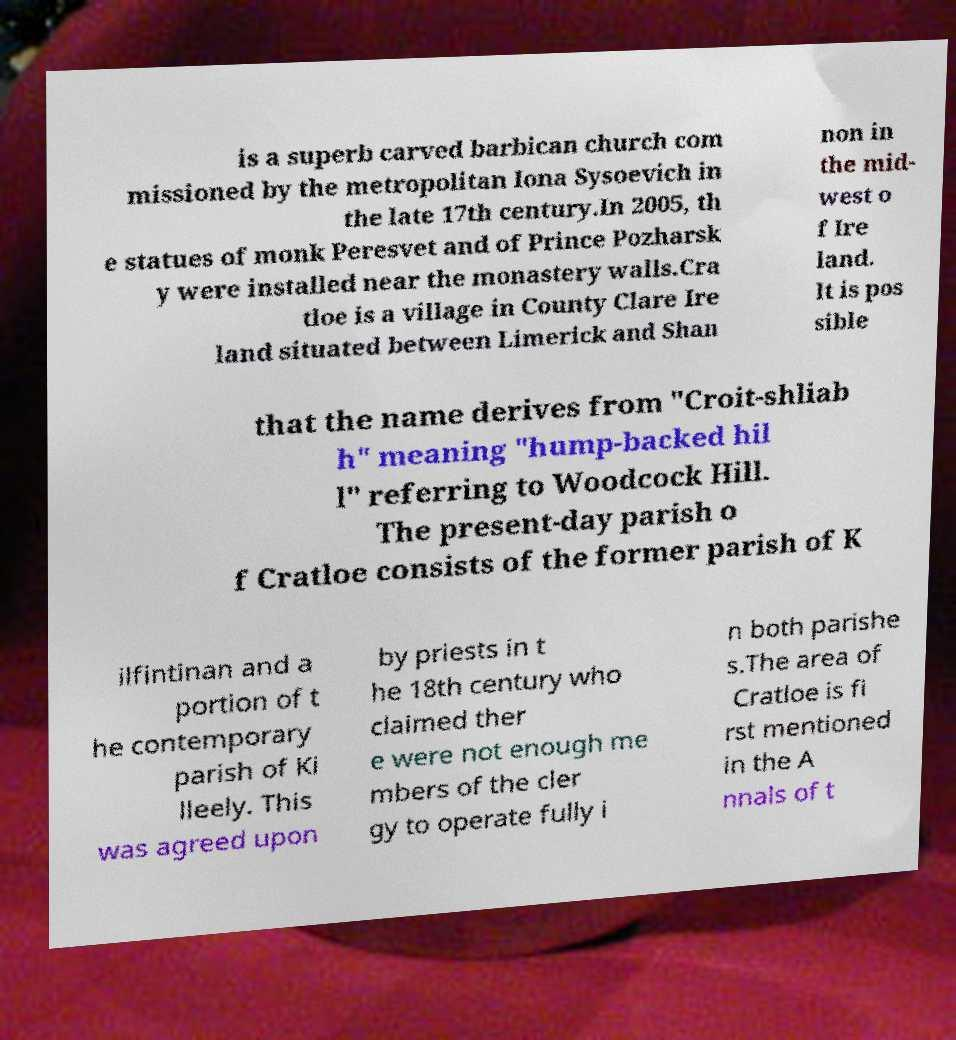Could you extract and type out the text from this image? is a superb carved barbican church com missioned by the metropolitan Iona Sysoevich in the late 17th century.In 2005, th e statues of monk Peresvet and of Prince Pozharsk y were installed near the monastery walls.Cra tloe is a village in County Clare Ire land situated between Limerick and Shan non in the mid- west o f Ire land. It is pos sible that the name derives from "Croit-shliab h" meaning "hump-backed hil l" referring to Woodcock Hill. The present-day parish o f Cratloe consists of the former parish of K ilfintinan and a portion of t he contemporary parish of Ki lleely. This was agreed upon by priests in t he 18th century who claimed ther e were not enough me mbers of the cler gy to operate fully i n both parishe s.The area of Cratloe is fi rst mentioned in the A nnals of t 